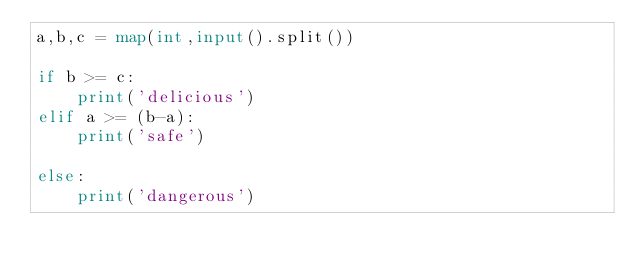Convert code to text. <code><loc_0><loc_0><loc_500><loc_500><_Python_>a,b,c = map(int,input().split())

if b >= c:
    print('delicious')
elif a >= (b-a):
    print('safe')

else:
    print('dangerous')</code> 